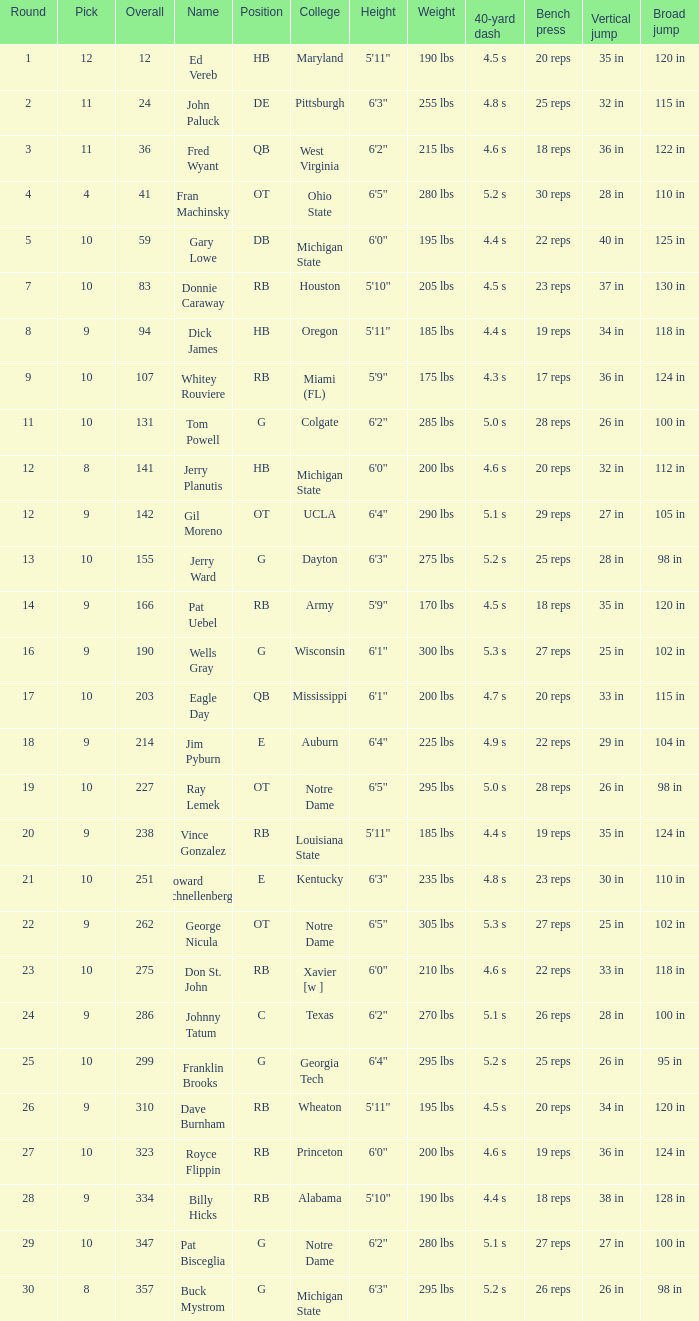What is the sum of rounds that has a pick of 9 and is named jim pyburn? 18.0. 